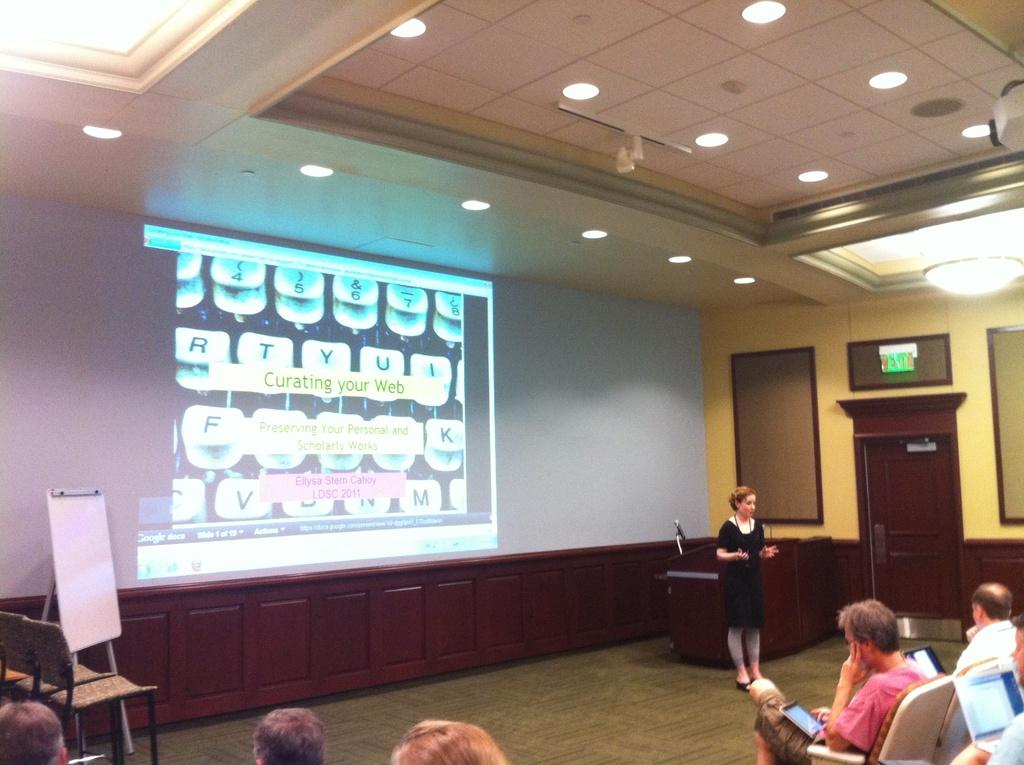<image>
Describe the image concisely. a lady in front of a screen with the letter T on it 